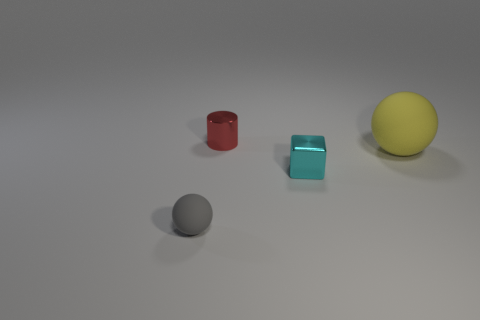There is a object that is made of the same material as the big ball; what is its color?
Your answer should be compact. Gray. Are there fewer matte things in front of the yellow matte thing than brown cubes?
Your response must be concise. No. There is a rubber thing right of the tiny red thing that is behind the matte thing that is left of the metallic cylinder; what size is it?
Your answer should be compact. Large. Are the ball that is right of the small rubber ball and the small red cylinder made of the same material?
Keep it short and to the point. No. Is there anything else that has the same shape as the tiny red thing?
Ensure brevity in your answer.  No. What number of objects are blue metallic things or small matte balls?
Offer a very short reply. 1. The other thing that is the same shape as the yellow matte object is what size?
Give a very brief answer. Small. Are there any other things that are the same size as the gray rubber thing?
Offer a terse response. Yes. How many other things are there of the same color as the small cylinder?
Offer a very short reply. 0. What number of balls are either tiny red shiny things or cyan metal objects?
Give a very brief answer. 0. 